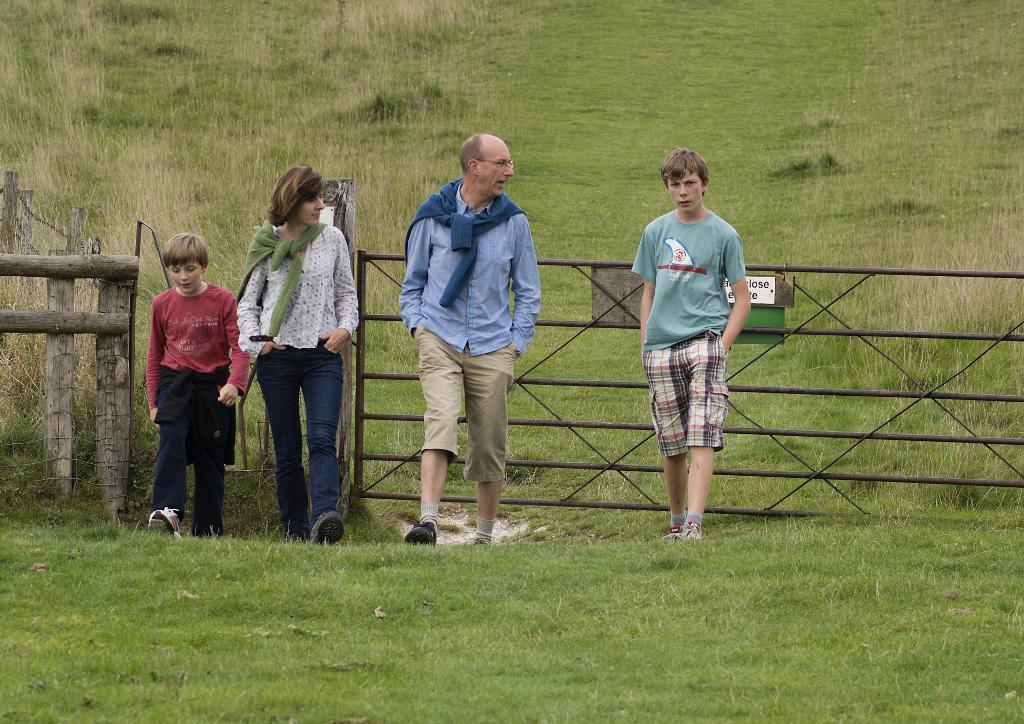How many people are in the image? There are four people in the image: a man, a woman, and two boys. What are the people in the image doing? They are standing on a field. What is visible behind the people in the image? There is fencing behind them, and a field is visible in the background. What type of amusement can be seen in the image? There is no amusement present in the image; it features a man, a woman, and two boys standing on a field with fencing behind them. Can you tell me how many tins are visible in the image? There are no tins present in the image. 